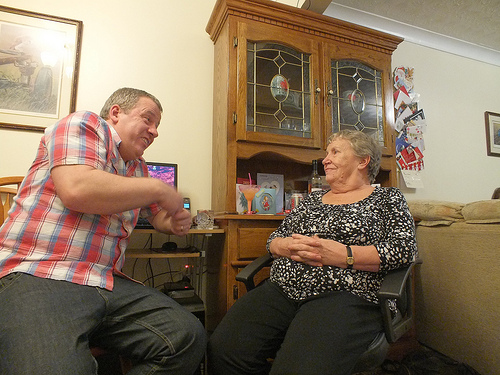<image>
Is there a couple on the room? No. The couple is not positioned on the room. They may be near each other, but the couple is not supported by or resting on top of the room. Where is the cupboard in relation to the lady? Is it behind the lady? Yes. From this viewpoint, the cupboard is positioned behind the lady, with the lady partially or fully occluding the cupboard. Where is the drink in relation to the phone? Is it to the right of the phone? Yes. From this viewpoint, the drink is positioned to the right side relative to the phone. 